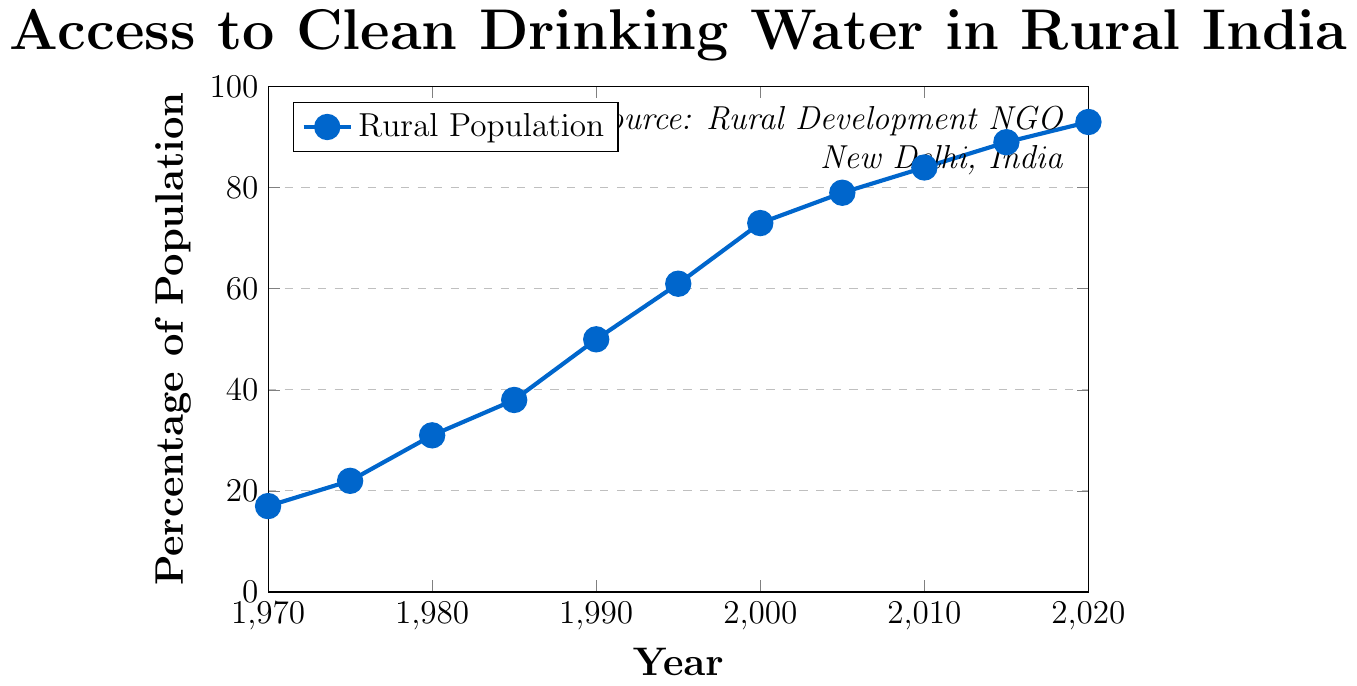What is the percentage of the rural population with access to clean drinking water in 1990? Locate the data point corresponding to the year 1990 on the x-axis and read the percentage value on the y-axis.
Answer: 50 How did the percentage of the population with access to clean drinking water change between 1980 and 1995? Identify the percentage values for the years 1980 and 1995, then calculate the difference: 61 (1995) - 31 (1980).
Answer: 30 During which decade was the most significant increase in access to clean drinking water observed? Calculate the increase in percentage for each decade: 1970-1980 (31-17=14), 1980-1990 (50-31=19), 1990-2000 (73-50=23), 2000-2010 (84-73=11), and 2010-2020 (93-84=9). The largest increase occurs between 1990 and 2000.
Answer: 1990-2000 By what percentage did access to clean drinking water increase from 1970 to 2020? Identify the percentage values for 1970 and 2020, then calculate the difference: 93 (2020) - 17 (1970).
Answer: 76 What was the average annual percentage increase in access to clean drinking water from 1970 to 2020? The total increase over 50 years is 76%. The average annual increase is 76% / 50 years.
Answer: 1.52 Which year marks the halfway point when 50% of the rural population had access to clean drinking water? Locate the data point where the y-value is 50%.
Answer: 1990 Compare the rate of increase from 1970 to 1985 and from 1995 to 2010. Which period had a higher annual growth rate? Calculate the annual growth rate for each period: 1970-1985 (38-17)/15 years = 1.4% per year; 1995-2010 (84-61)/15 years = 1.53% per year.
Answer: 1995-2010 How many years did it take for the percentage to increase from 50% to 84%? Identify the years corresponding to 50% (1990) and 84% (2010), then calculate the difference: 2010 - 1990.
Answer: 20 What visual element is used to identify the data points in the plot? Observe the plot and note what visual representation marks the data points.
Answer: Markers (filled circles) What is the color of the line representing the rural population's access to clean drinking water? Observe the color of the line in the plot.
Answer: Blue 